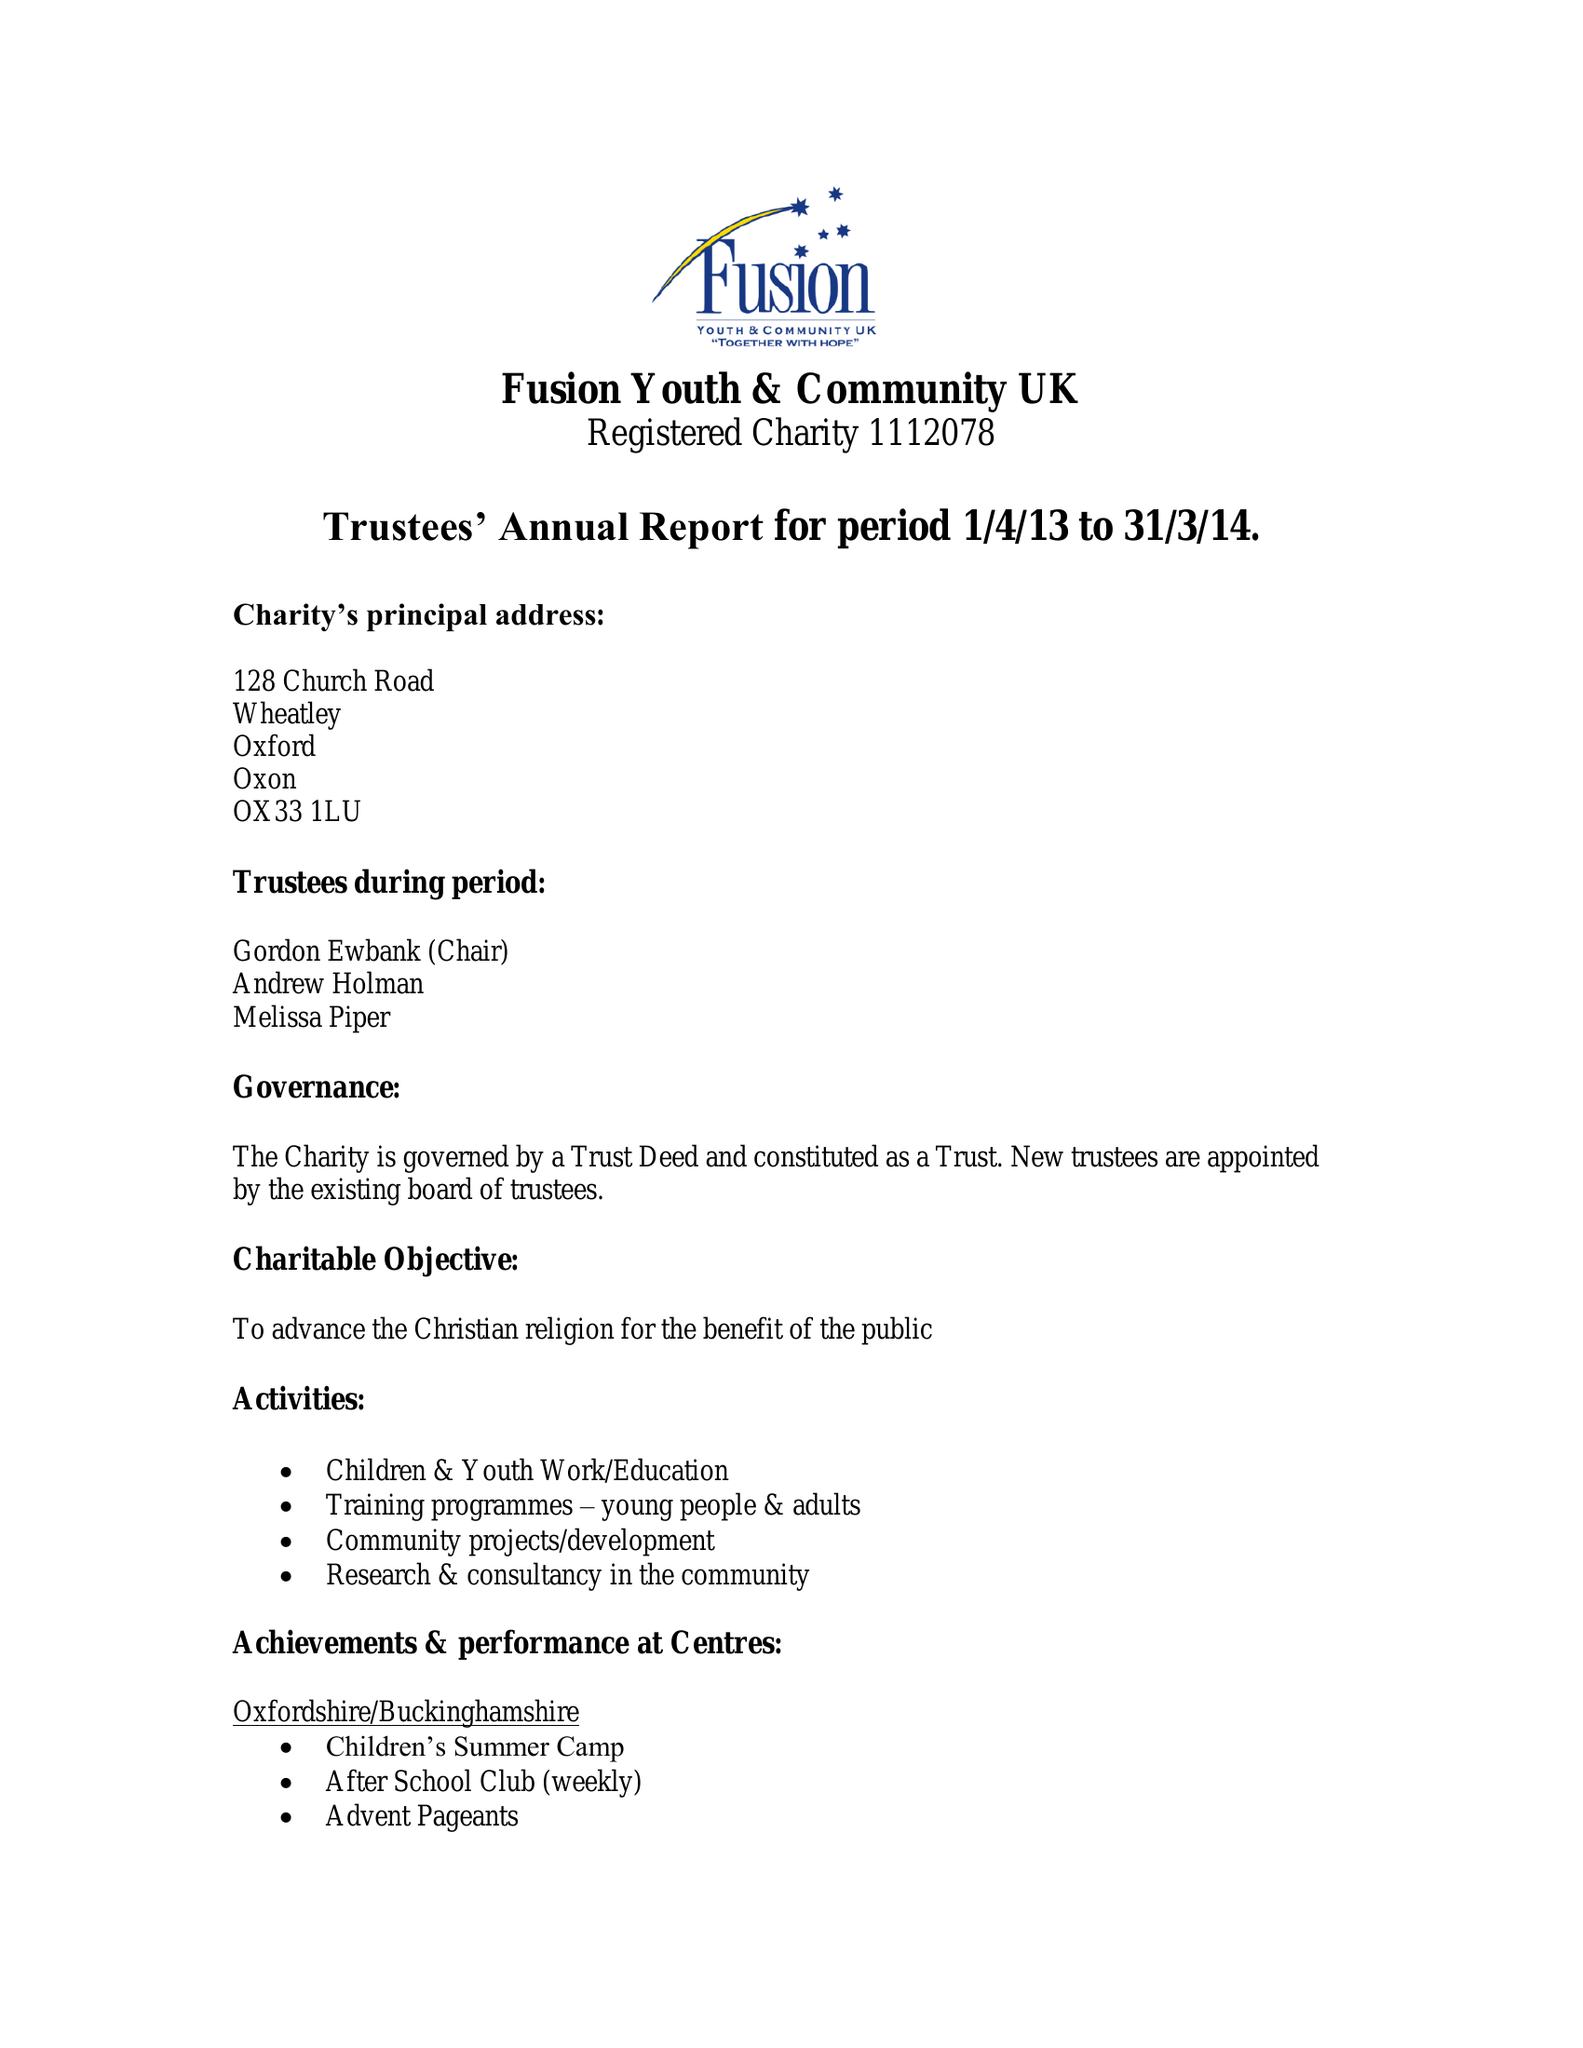What is the value for the report_date?
Answer the question using a single word or phrase. 2014-03-31 